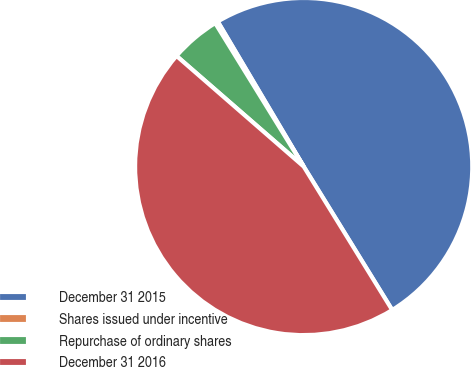Convert chart. <chart><loc_0><loc_0><loc_500><loc_500><pie_chart><fcel>December 31 2015<fcel>Shares issued under incentive<fcel>Repurchase of ordinary shares<fcel>December 31 2016<nl><fcel>49.72%<fcel>0.28%<fcel>4.81%<fcel>45.19%<nl></chart> 